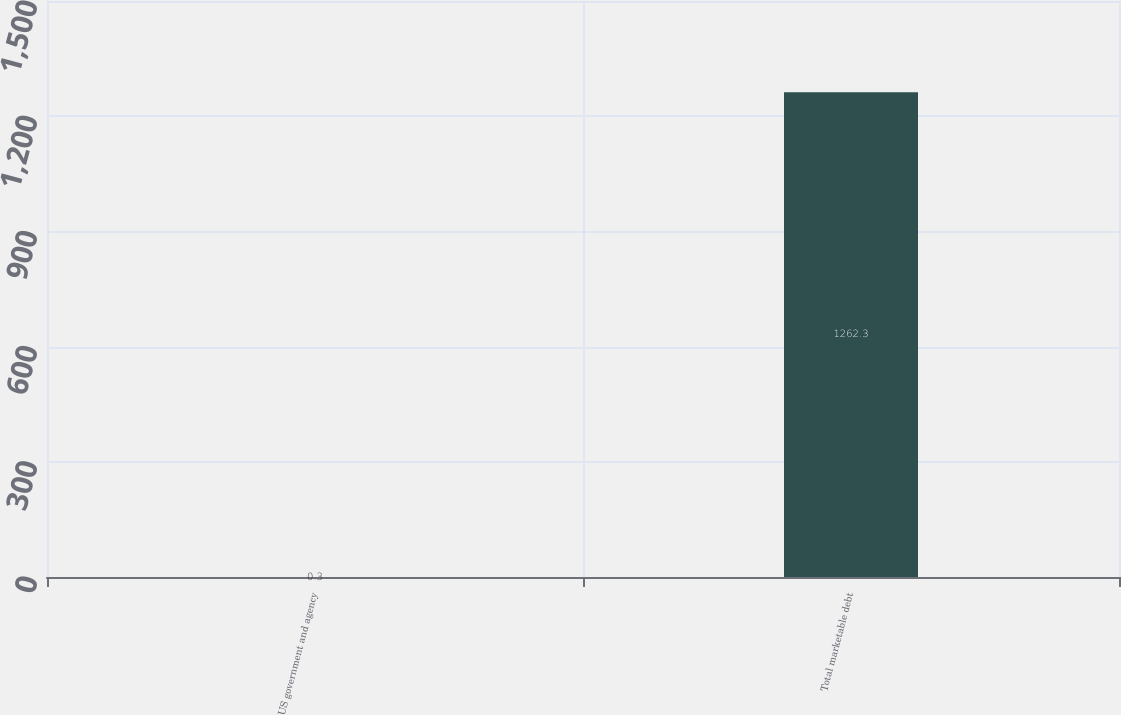<chart> <loc_0><loc_0><loc_500><loc_500><bar_chart><fcel>US government and agency<fcel>Total marketable debt<nl><fcel>0.3<fcel>1262.3<nl></chart> 